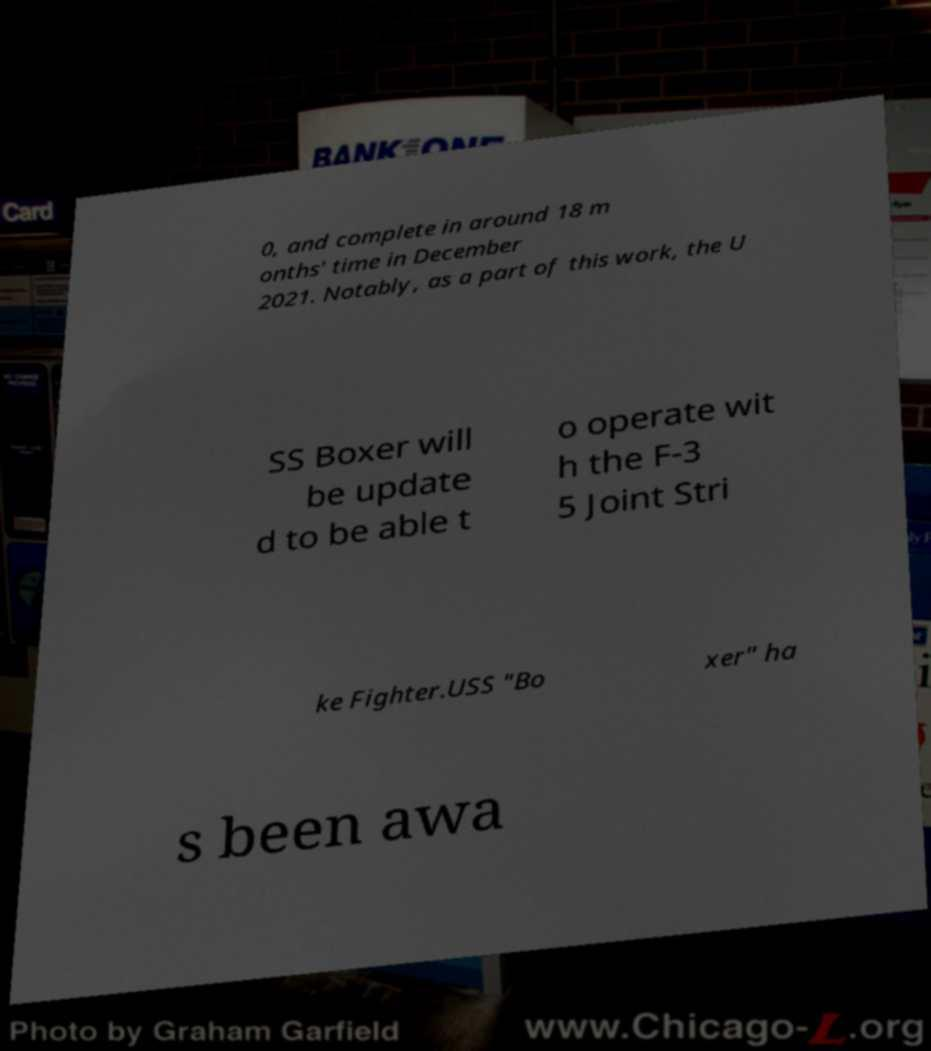Can you read and provide the text displayed in the image?This photo seems to have some interesting text. Can you extract and type it out for me? 0, and complete in around 18 m onths' time in December 2021. Notably, as a part of this work, the U SS Boxer will be update d to be able t o operate wit h the F-3 5 Joint Stri ke Fighter.USS "Bo xer" ha s been awa 